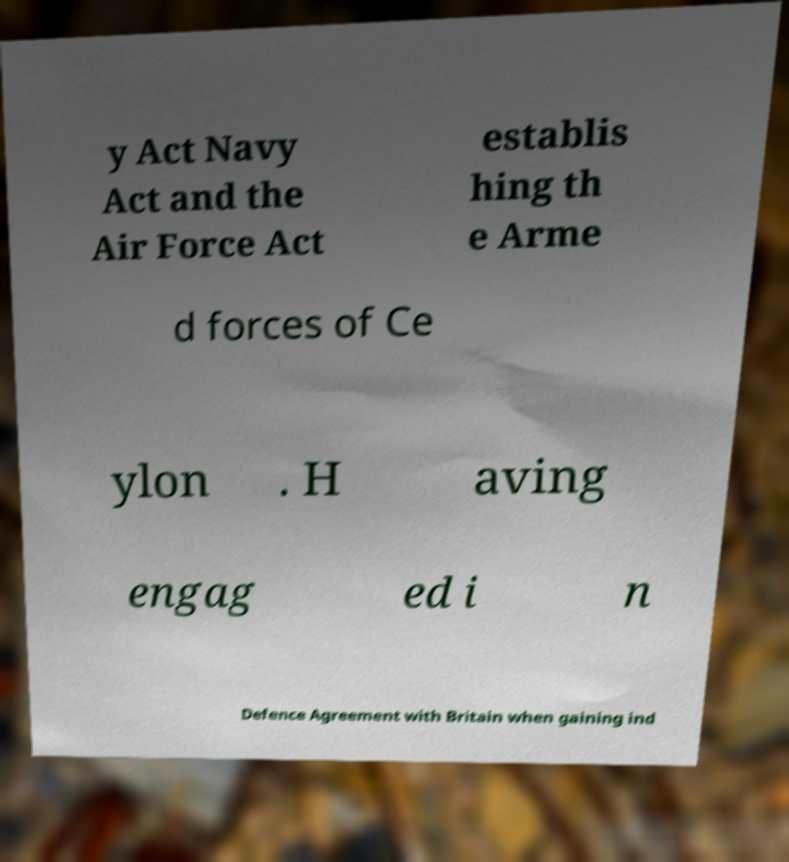For documentation purposes, I need the text within this image transcribed. Could you provide that? y Act Navy Act and the Air Force Act establis hing th e Arme d forces of Ce ylon . H aving engag ed i n Defence Agreement with Britain when gaining ind 